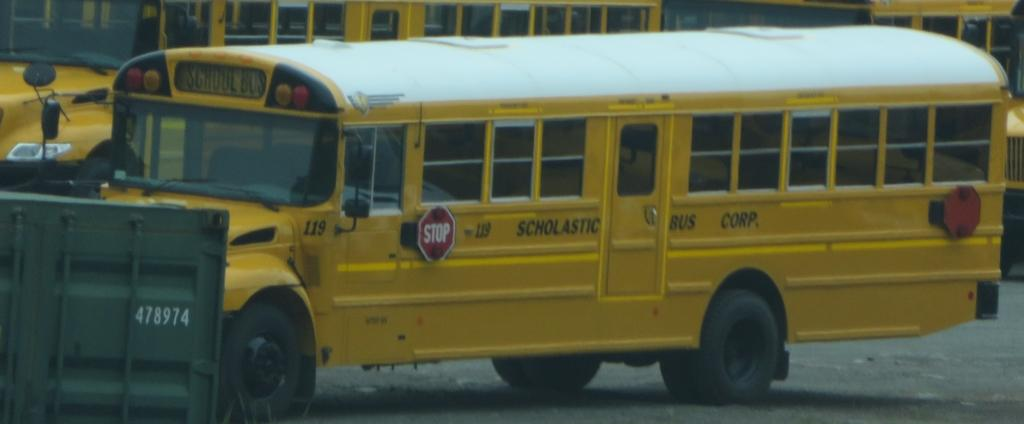<image>
Summarize the visual content of the image. A Scholastic Bus Corporation school bus is parked in a lot. 